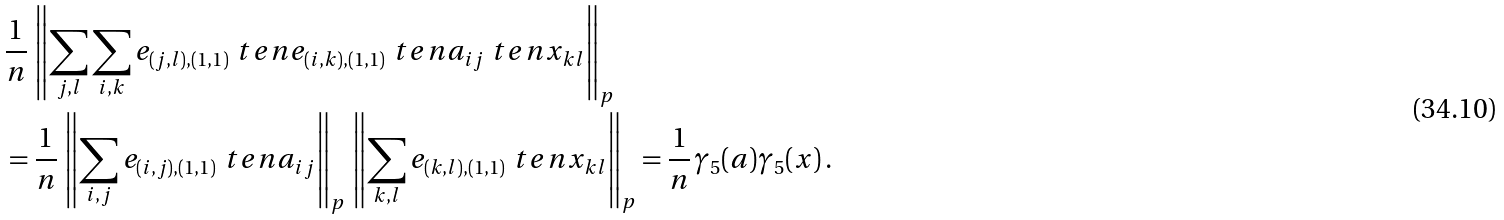Convert formula to latex. <formula><loc_0><loc_0><loc_500><loc_500>& \frac { 1 } { n } \, \left \| \sum _ { j , l } \sum _ { i , k } e _ { ( j , l ) , ( 1 , 1 ) } \ t e n e _ { ( i , k ) , ( 1 , 1 ) } \ t e n a _ { i j } \ t e n x _ { k l } \right \| _ { p } \\ & = \frac { 1 } { n } \, \left \| \sum _ { i , j } e _ { ( i , j ) , ( 1 , 1 ) } \ t e n a _ { i j } \right \| _ { p } \, \left \| \sum _ { k , l } e _ { ( k , l ) , ( 1 , 1 ) } \ t e n x _ { k l } \right \| _ { p } = \frac { 1 } { n } \, \gamma _ { 5 } ( a ) \gamma _ { 5 } ( x ) \, .</formula> 